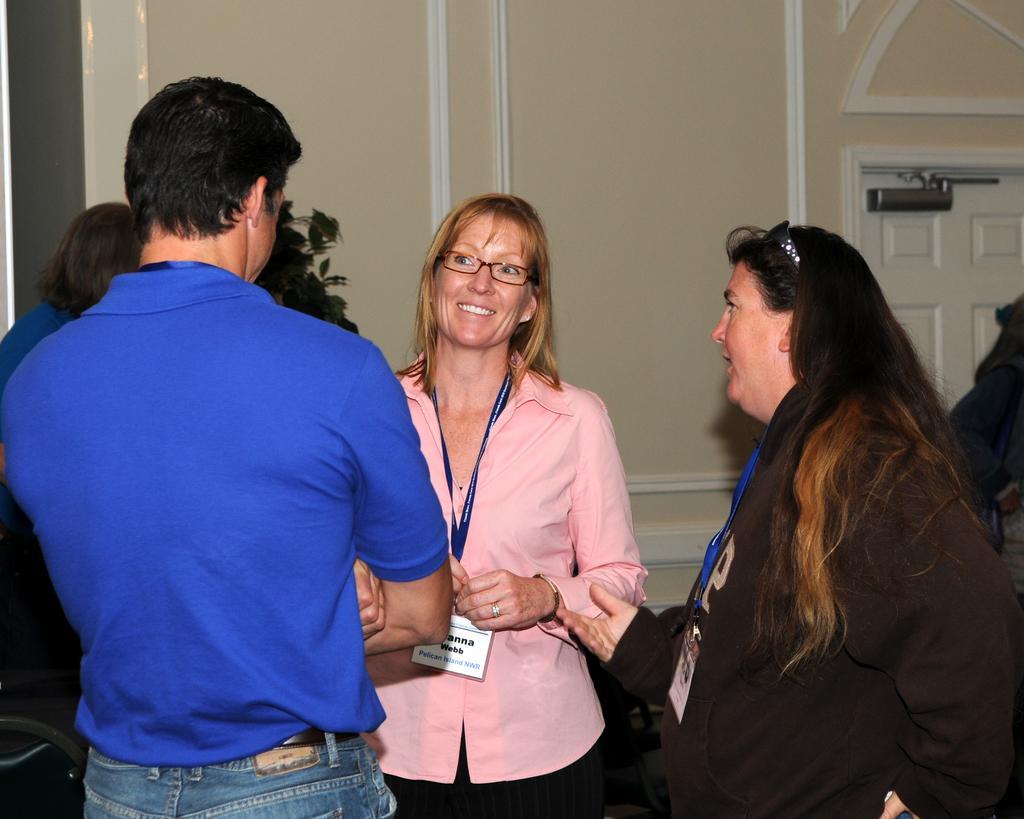In one or two sentences, can you explain what this image depicts? In this picture there are people standing, among them there is a woman smiling and wire tag. In the background of the image we can see a door, wall and plant. 